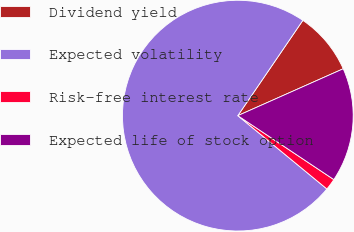Convert chart. <chart><loc_0><loc_0><loc_500><loc_500><pie_chart><fcel>Dividend yield<fcel>Expected volatility<fcel>Risk-free interest rate<fcel>Expected life of stock option<nl><fcel>8.81%<fcel>73.57%<fcel>1.61%<fcel>16.01%<nl></chart> 